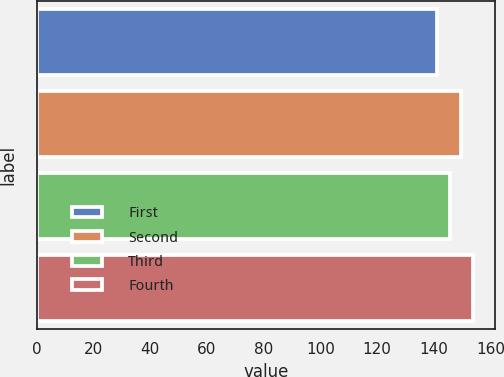<chart> <loc_0><loc_0><loc_500><loc_500><bar_chart><fcel>First<fcel>Second<fcel>Third<fcel>Fourth<nl><fcel>141.26<fcel>149.5<fcel>145.57<fcel>153.86<nl></chart> 